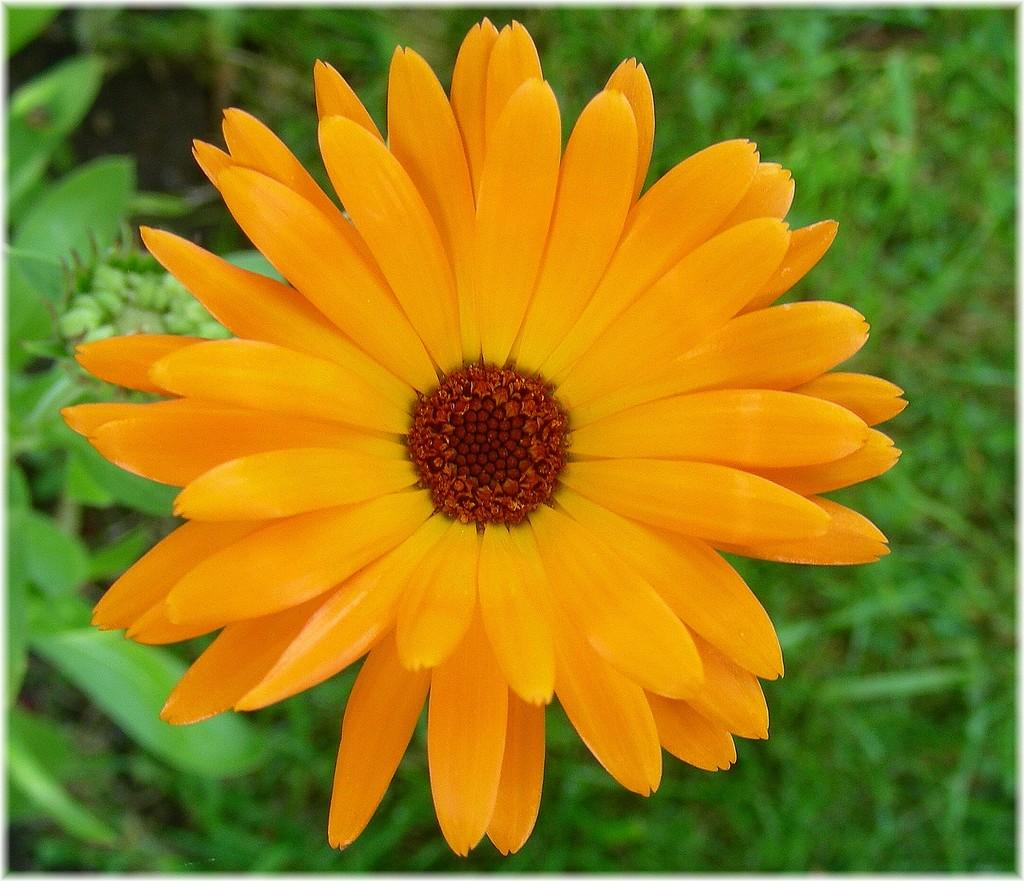What color is the flower in the image? The flower in the image is orange. Where is the flower located in the image? The flower is in the front of the image. What color are the leaves in the background of the image? The leaves in the background of the image are green. How would you describe the background of the image? The background of the image is slightly blurry. How does the flower help increase the profit of the business in the image? There is no mention of a business or profit in the image, and the flower is not depicted as having any such function. 